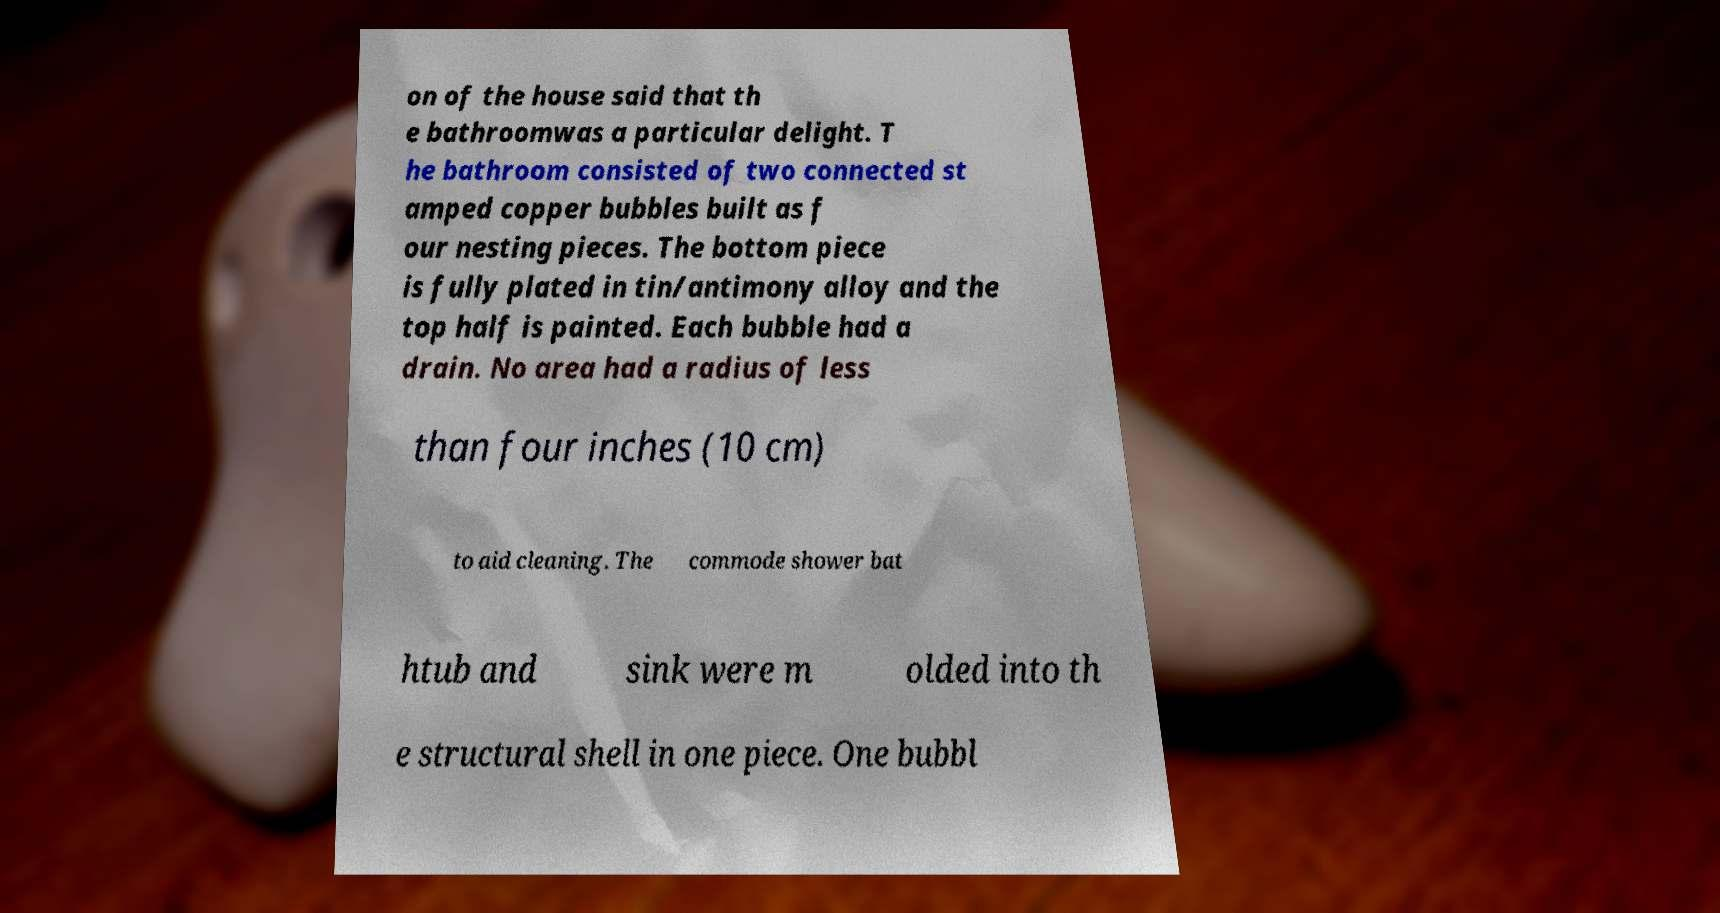There's text embedded in this image that I need extracted. Can you transcribe it verbatim? on of the house said that th e bathroomwas a particular delight. T he bathroom consisted of two connected st amped copper bubbles built as f our nesting pieces. The bottom piece is fully plated in tin/antimony alloy and the top half is painted. Each bubble had a drain. No area had a radius of less than four inches (10 cm) to aid cleaning. The commode shower bat htub and sink were m olded into th e structural shell in one piece. One bubbl 